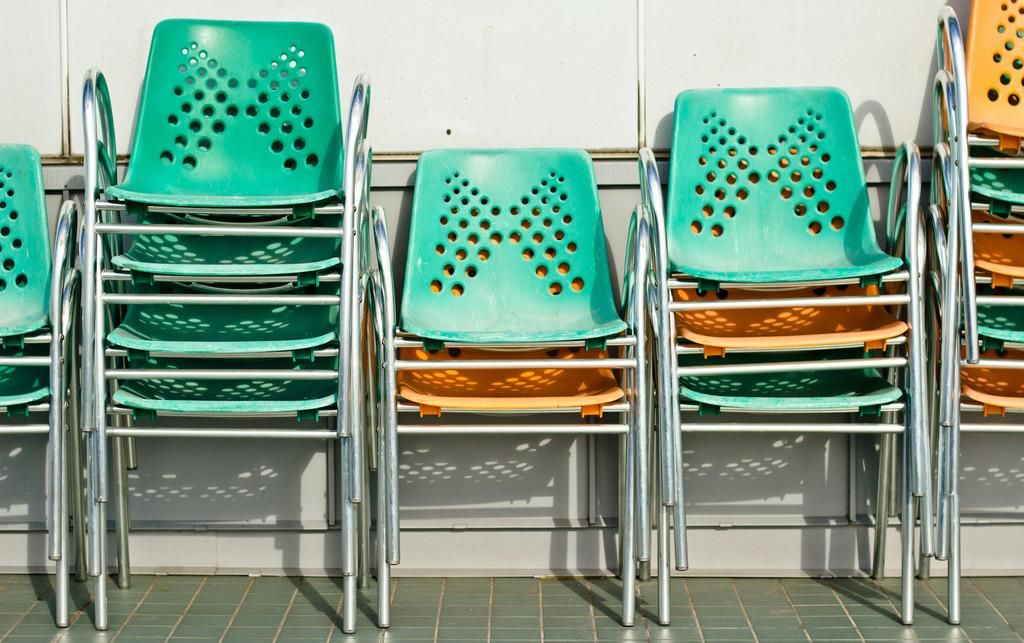What is the main subject of the image? The main subject of the image is a group of chairs. How are the chairs arranged in the image? The chairs are placed one on the other on the floor. What can be seen in the background of the image? There is a wall visible in the image. What type of soda is being poured on the chairs in the image? There is no soda present in the image; the chairs are simply stacked on the floor. Can you see a bear interacting with the chairs in the image? There is no bear present in the image; it only features a group of chairs stacked on the floor. 